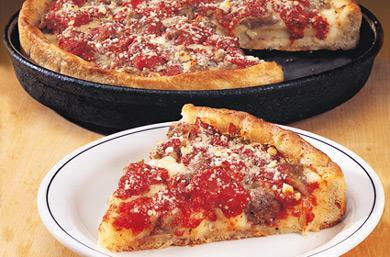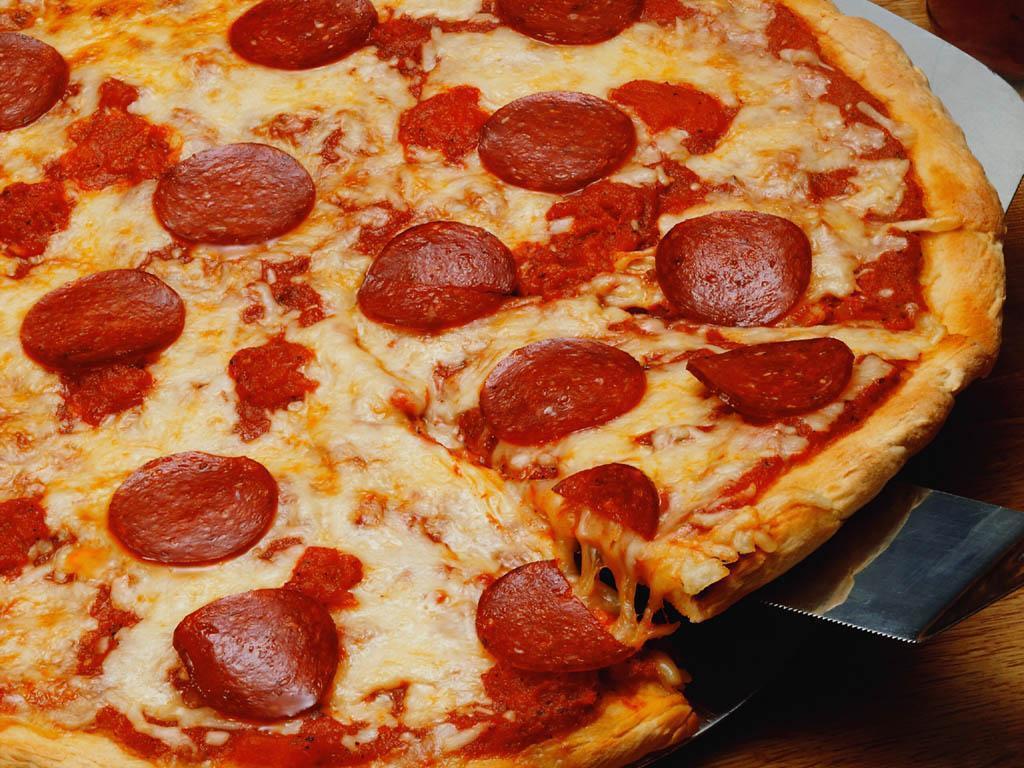The first image is the image on the left, the second image is the image on the right. Considering the images on both sides, is "The pizza in the image to the right has green peppers on it." valid? Answer yes or no. No. The first image is the image on the left, the second image is the image on the right. For the images displayed, is the sentence "The right image shows one complete unsliced pizza with multiple hamburgers on top of it, and the left image shows a pizza with at least one slice not on its round dark pan." factually correct? Answer yes or no. No. 